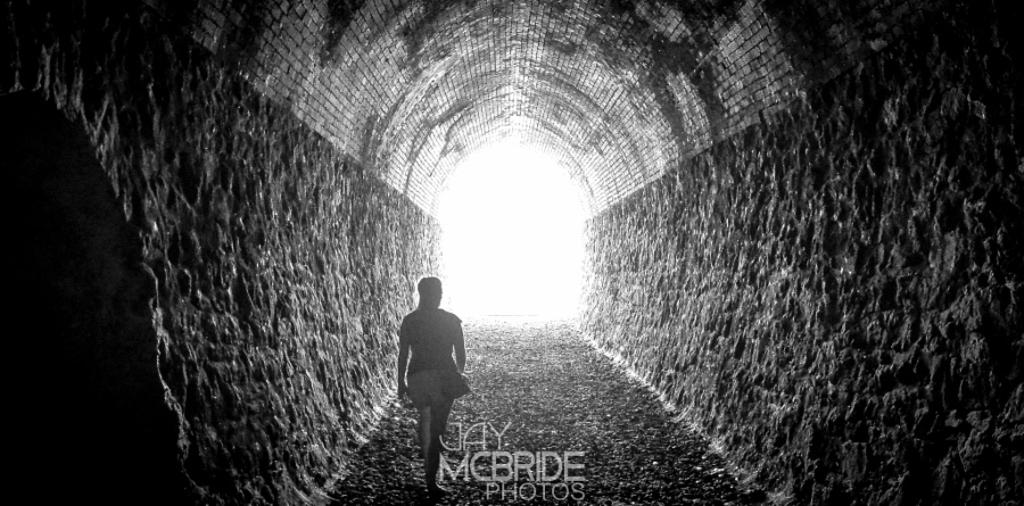Who is present in the image? There is a woman in the image. What is the woman doing in the image? The woman is walking. What natural feature can be seen at the bottom of the image? There is a waterfall at the bottom of the image. What type of car is the woman driving in the image? There is no car present in the image; the woman is walking. What kind of suit or apparel is the woman wearing in the image? The provided facts do not mention any specific clothing or apparel that the woman is wearing. 